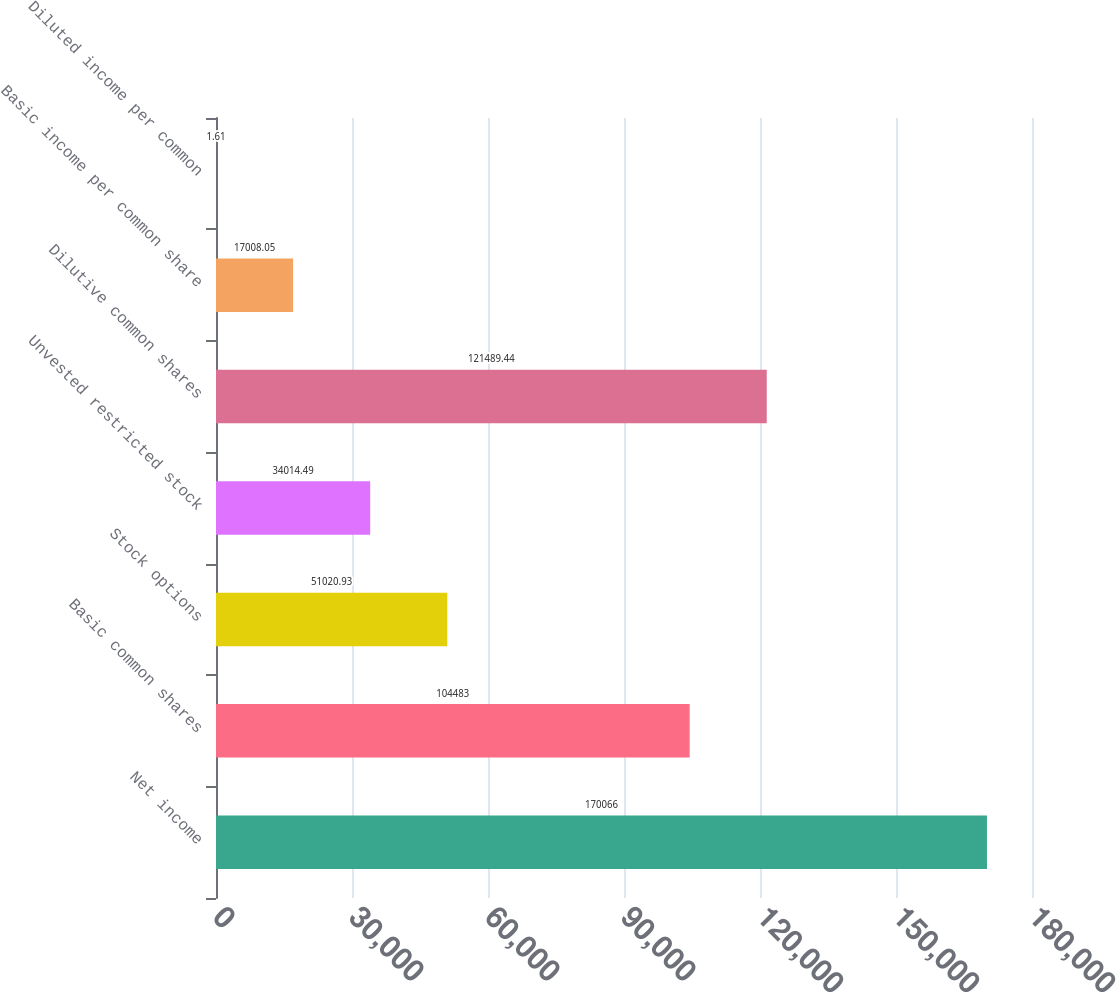Convert chart. <chart><loc_0><loc_0><loc_500><loc_500><bar_chart><fcel>Net income<fcel>Basic common shares<fcel>Stock options<fcel>Unvested restricted stock<fcel>Dilutive common shares<fcel>Basic income per common share<fcel>Diluted income per common<nl><fcel>170066<fcel>104483<fcel>51020.9<fcel>34014.5<fcel>121489<fcel>17008<fcel>1.61<nl></chart> 